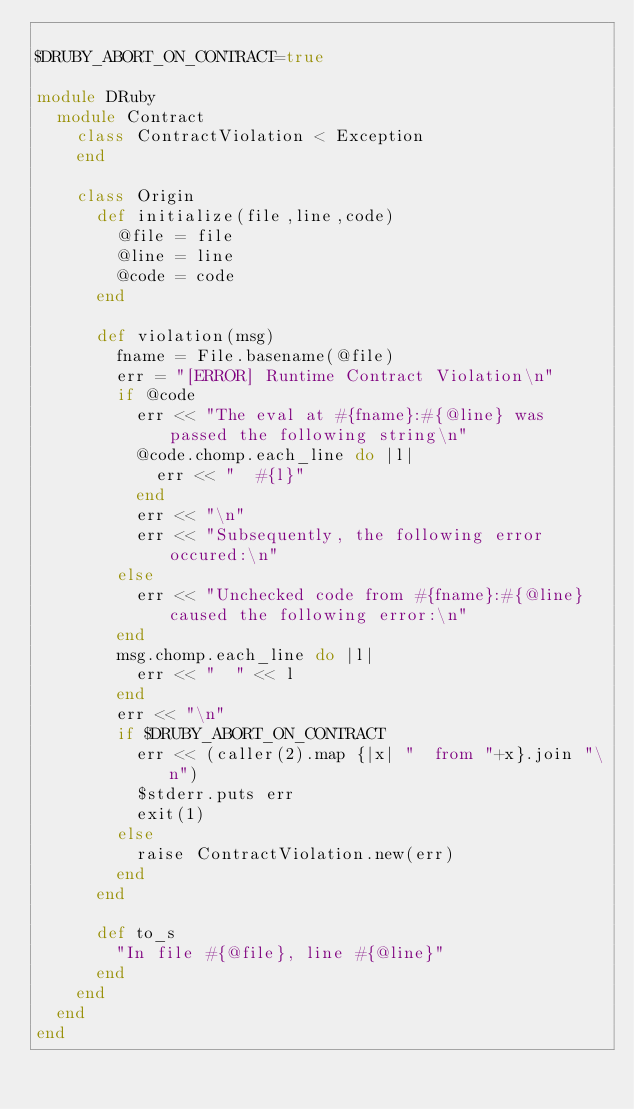Convert code to text. <code><loc_0><loc_0><loc_500><loc_500><_Ruby_>
$DRUBY_ABORT_ON_CONTRACT=true

module DRuby
  module Contract
    class ContractViolation < Exception
    end

    class Origin
      def initialize(file,line,code)
        @file = file
        @line = line
        @code = code
      end

      def violation(msg)
        fname = File.basename(@file)
        err = "[ERROR] Runtime Contract Violation\n"
        if @code
          err << "The eval at #{fname}:#{@line} was passed the following string\n"
          @code.chomp.each_line do |l|
            err << "  #{l}"
          end
          err << "\n"
          err << "Subsequently, the following error occured:\n"
        else
          err << "Unchecked code from #{fname}:#{@line} caused the following error:\n"
        end
        msg.chomp.each_line do |l|
          err << "  " << l
        end
        err << "\n"
        if $DRUBY_ABORT_ON_CONTRACT
          err << (caller(2).map {|x| "  from "+x}.join "\n")
          $stderr.puts err
          exit(1)
        else
          raise ContractViolation.new(err)
        end
      end
      
      def to_s
        "In file #{@file}, line #{@line}"
      end
    end
  end
end
</code> 